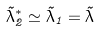Convert formula to latex. <formula><loc_0><loc_0><loc_500><loc_500>\tilde { \lambda } _ { 2 } ^ { \ast } \simeq \tilde { \lambda } _ { 1 } = \tilde { \lambda }</formula> 